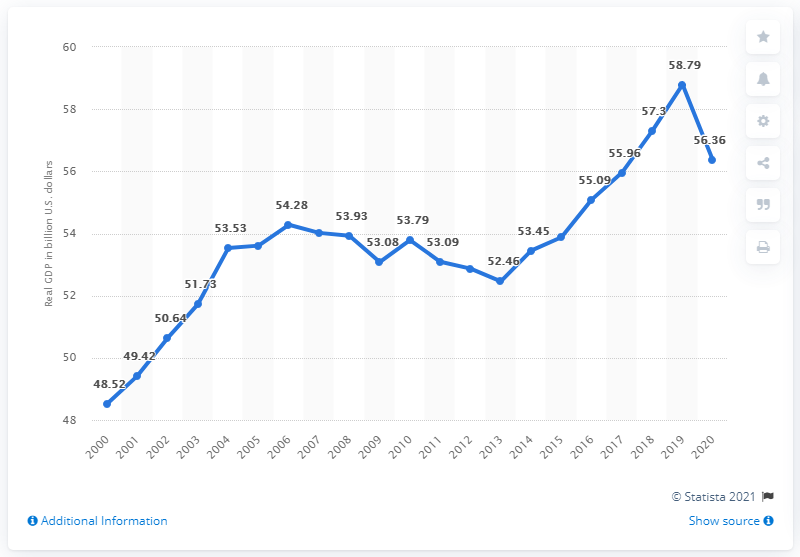Mention a couple of crucial points in this snapshot. The Gross Domestic Product (GDP) of Maine in 2020 was $56.36 billion. In 2018, the Gross Domestic Product (GDP) of Maine was 58.79 billion dollars. 